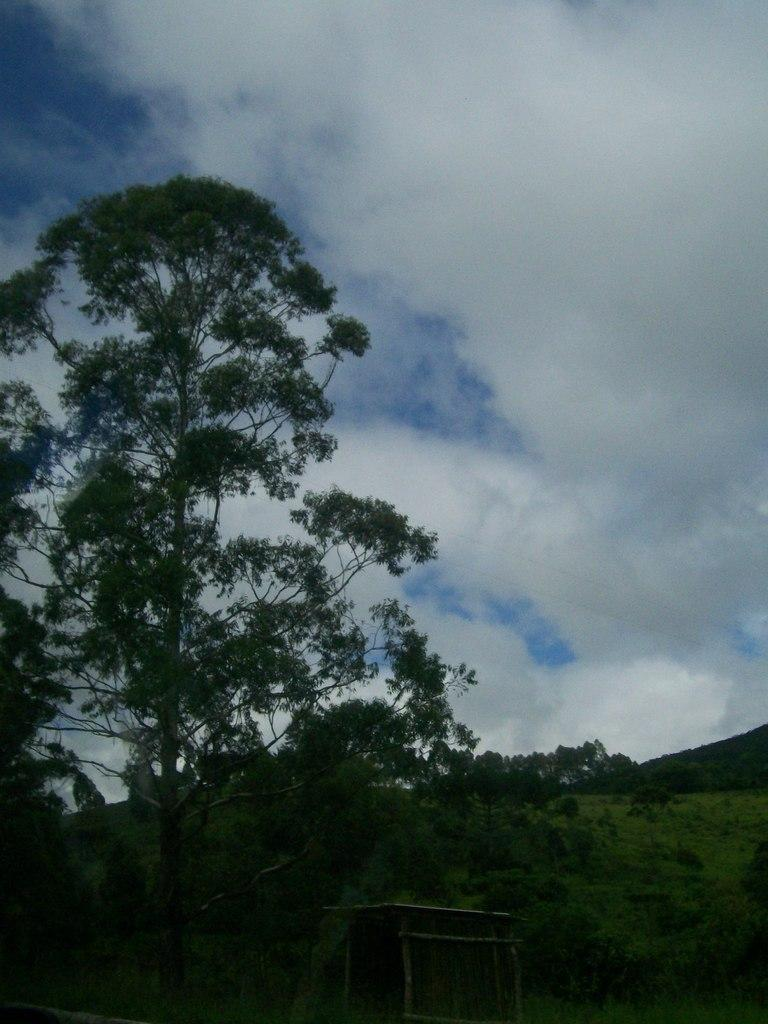What structure is located on the ground in the image? There is a shed on the ground in the image. What can be seen in the background of the image? There are trees in the background of the image. What is visible in the sky at the top of the image? Clouds are visible in the sky at the top of the image. Can you tell me how many birds are sitting on the shed in the image? There are no birds present on the shed or in the image. What type of jelly is being used to hold the shed together in the image? There is no jelly present in the image, and the shed is not being held together by any jelly. 